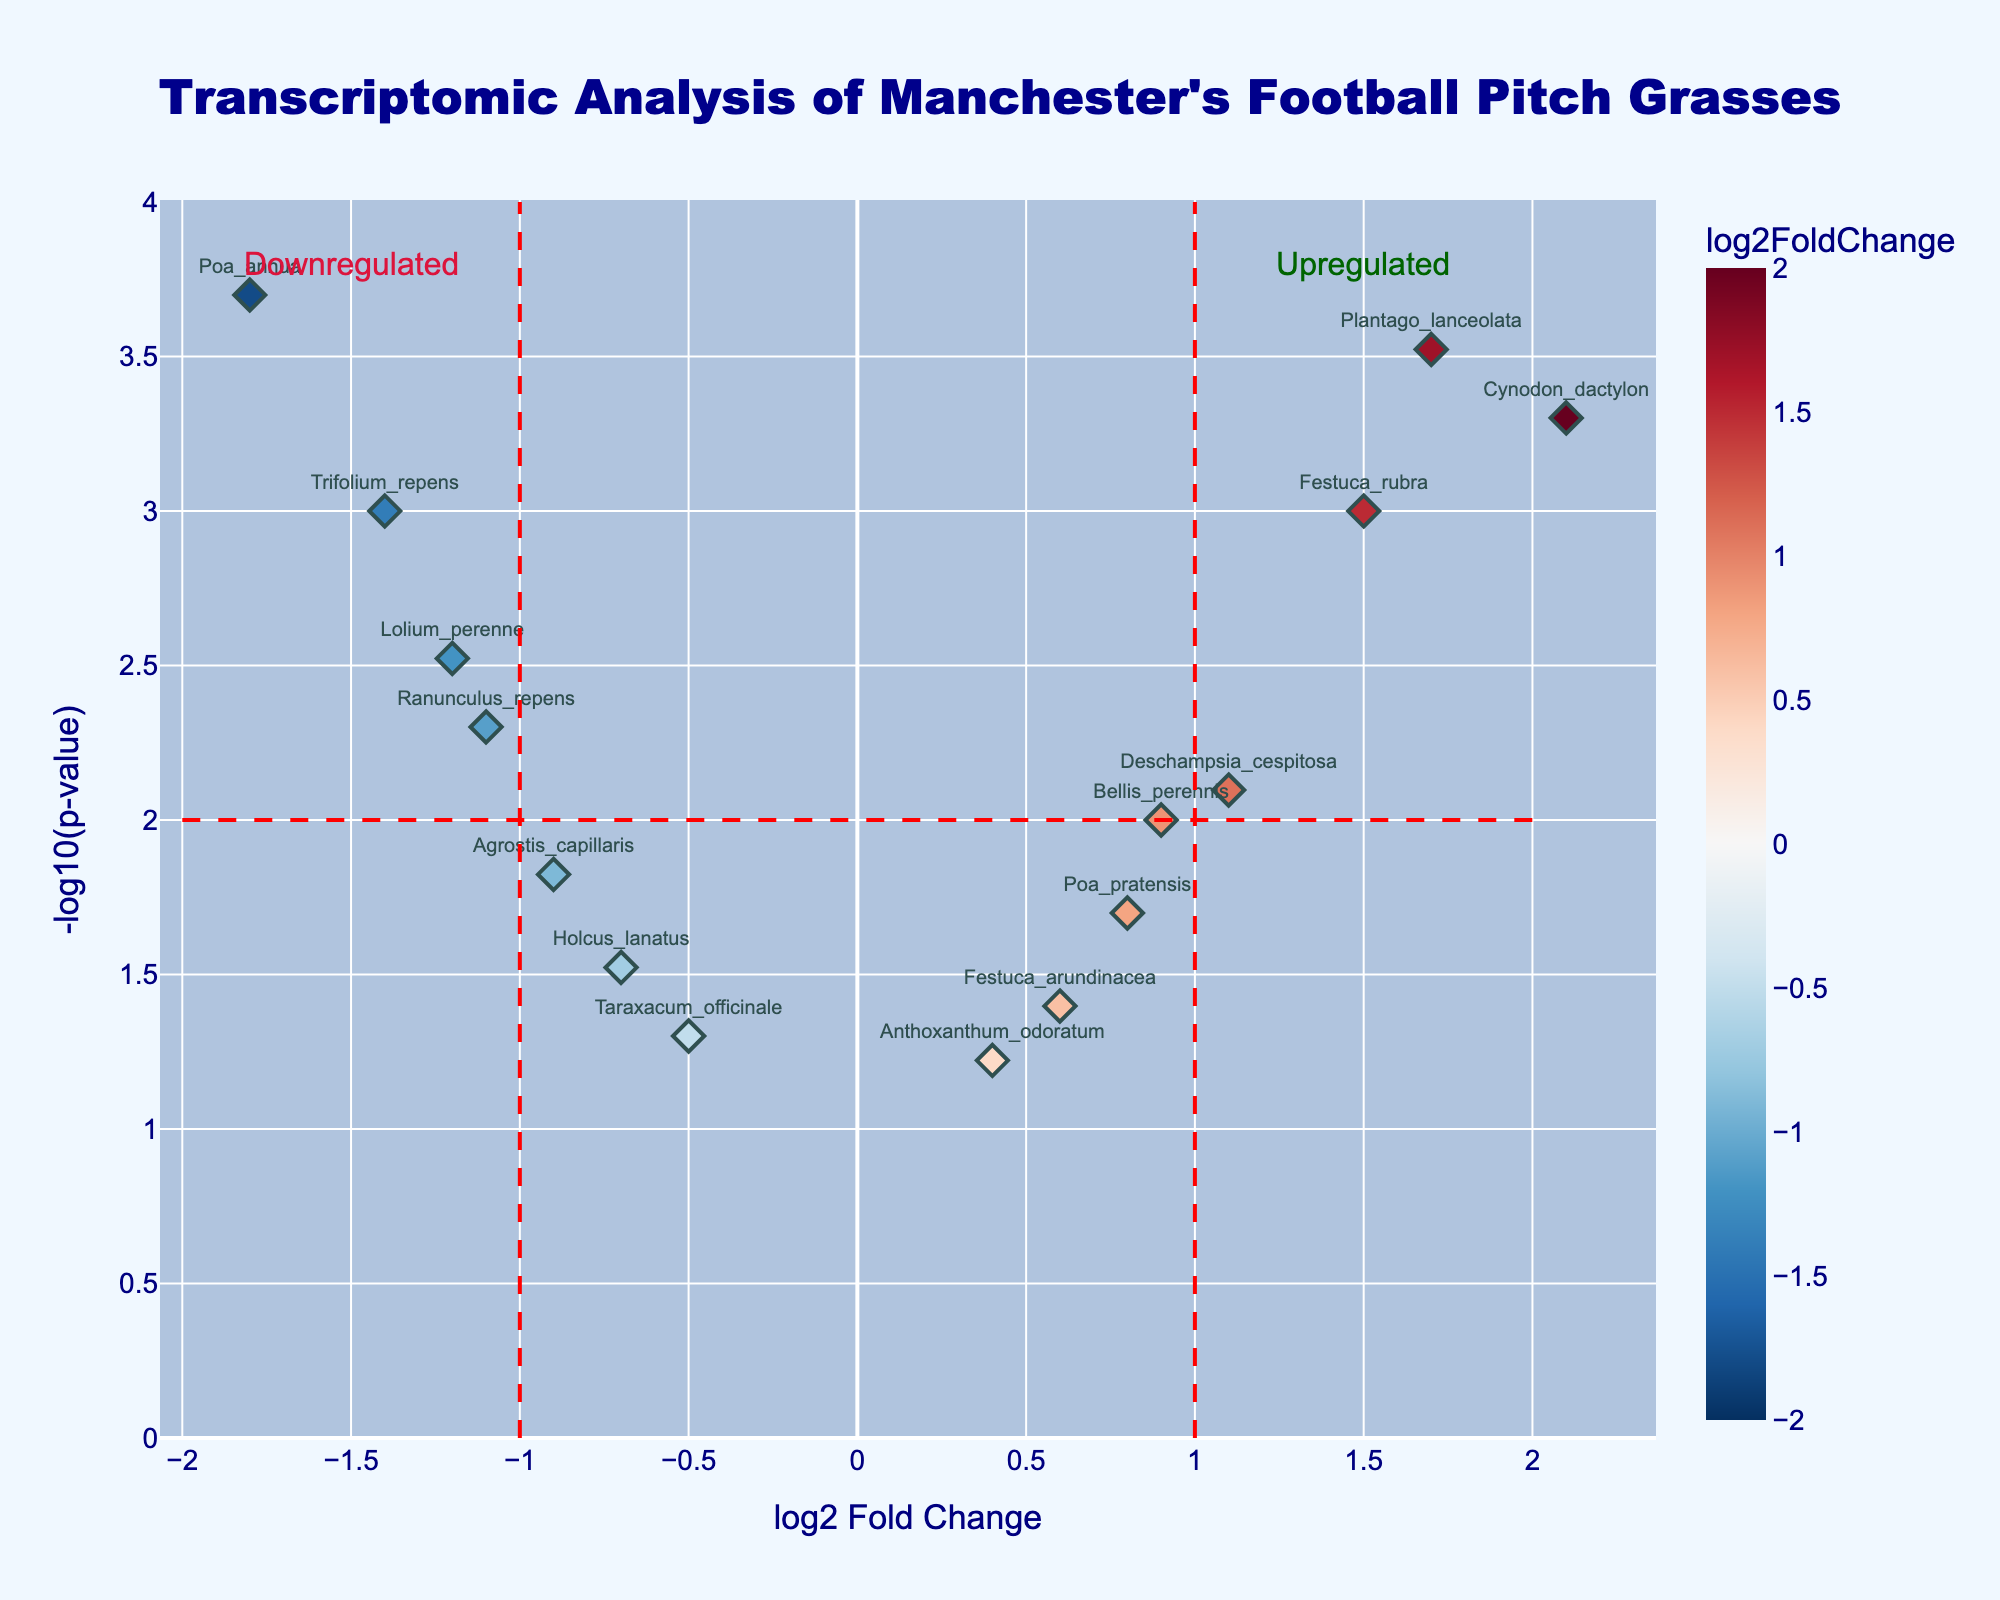What is the title of the volcano plot? The title of the plot is usually displayed prominently at the top of the figure. Here, it is clearly stated, "Transcriptomic Analysis of Manchester's Football Pitch Grasses".
Answer: Transcriptomic Analysis of Manchester's Football Pitch Grasses How is the color of the points determined in the plot? The color of the points is determined by the log2FoldChange value. The scale is color-coded such that negative values (downregulated genes) are one color while positive values (upregulated genes) are another color.
Answer: By log2FoldChange value Which gene has the highest log2FoldChange? To find the gene with the highest log2FoldChange, you look for the point farthest to the right on the x-axis. The gene is Cynodon_dactylon with a log2FoldChange of 2.1.
Answer: Cynodon_dactylon Which genes are upregulated and have a p-value less than 0.001? First, look for genes with a positive log2FoldChange (right side of the plot) and then check those with -log10(pValue) greater than 3 (since p-value < 0.001). The relevant genes are Cynodon_dactylon and Plantago_lanceolata.
Answer: Cynodon_dactylon, Plantago_lanceolata How many genes have a log2FoldChange between -1 and 1? To answer, count the data points between -1 and 1 on the x-axis. The genes within this range are Poa_pratensis, Festuca_arundinacea, Deschampsia_cespitosa, Holcus_lanatus, Anthoxanthum_odoratum, Taraxacum_officinale, and Bellis_perennis.
Answer: 7 Which gene is the most downregulated? The most downregulated gene will have the most negative log2FoldChange. Here, it is the gene Poa_annua with a log2FoldChange of -1.8.
Answer: Poa_annua What is the -log10(p-value) of Festuca_rubra? Locate the gene Festuca_rubra in the plot or the data, and find its vertical position on the y-axis, which represents -log10(p-value). Festuca_rubra has a p-value of 0.001, so -log10(0.001) is 3.
Answer: 3 How many genes are significantly downregulated? (consider sig. as log2FoldChange < -1 and p-value < 0.05) Identify genes with log2FoldChange < -1 and -log10(pValue) > 1.3 (since p < 0.05). The relevant genes are Lolium_perenne, Poa_annua, Trifolium_repens, and Ranunculus_repens.
Answer: 4 